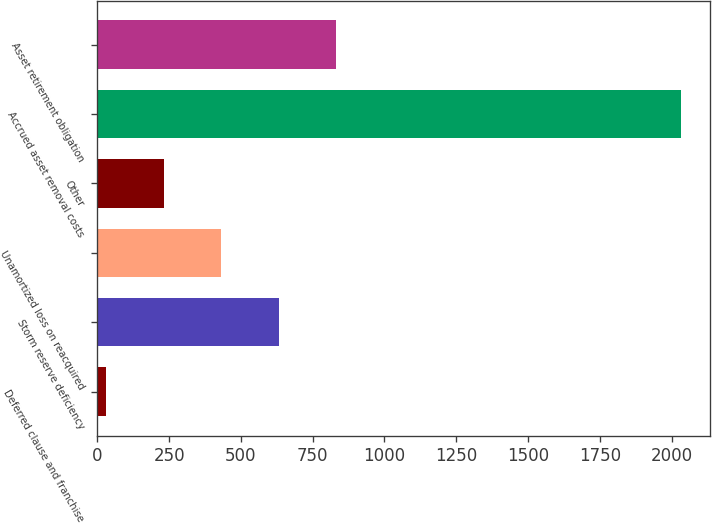Convert chart. <chart><loc_0><loc_0><loc_500><loc_500><bar_chart><fcel>Deferred clause and franchise<fcel>Storm reserve deficiency<fcel>Unamortized loss on reacquired<fcel>Other<fcel>Accrued asset removal costs<fcel>Asset retirement obligation<nl><fcel>32<fcel>632.3<fcel>432.2<fcel>232.1<fcel>2033<fcel>832.4<nl></chart> 